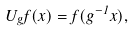<formula> <loc_0><loc_0><loc_500><loc_500>U _ { g } f ( x ) = f ( g ^ { - 1 } x ) ,</formula> 